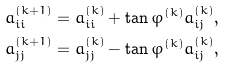<formula> <loc_0><loc_0><loc_500><loc_500>a _ { i i } ^ { ( k + 1 ) } & = a _ { i i } ^ { ( k ) } + \tan \varphi ^ { ( k ) } a _ { i j } ^ { ( k ) } , \\ a _ { j j } ^ { ( k + 1 ) } & = a _ { j j } ^ { ( k ) } - \tan \varphi ^ { ( k ) } a _ { i j } ^ { ( k ) } ,</formula> 